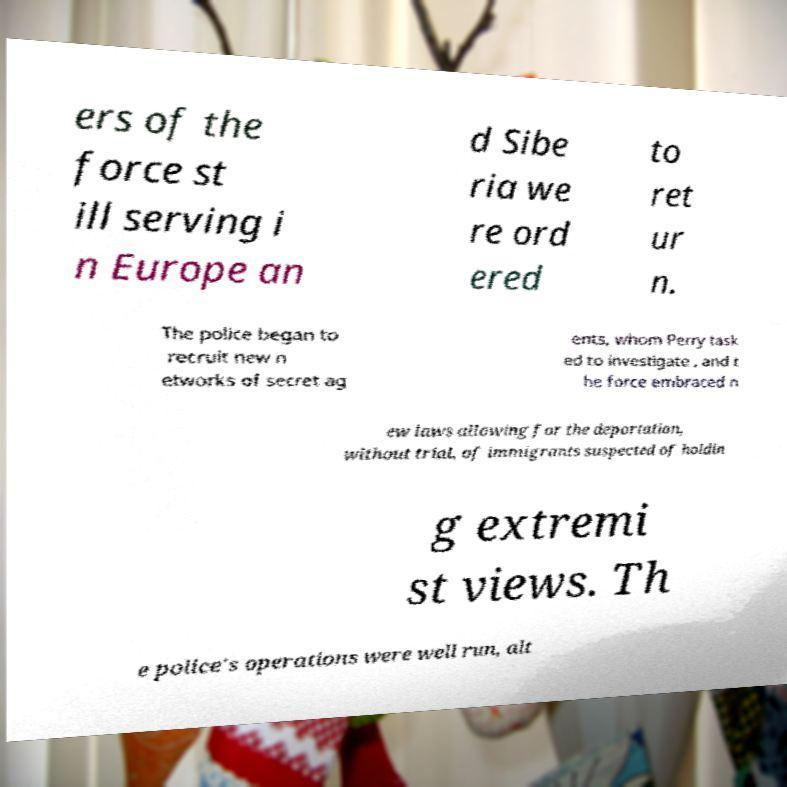I need the written content from this picture converted into text. Can you do that? ers of the force st ill serving i n Europe an d Sibe ria we re ord ered to ret ur n. The police began to recruit new n etworks of secret ag ents, whom Perry task ed to investigate , and t he force embraced n ew laws allowing for the deportation, without trial, of immigrants suspected of holdin g extremi st views. Th e police's operations were well run, alt 